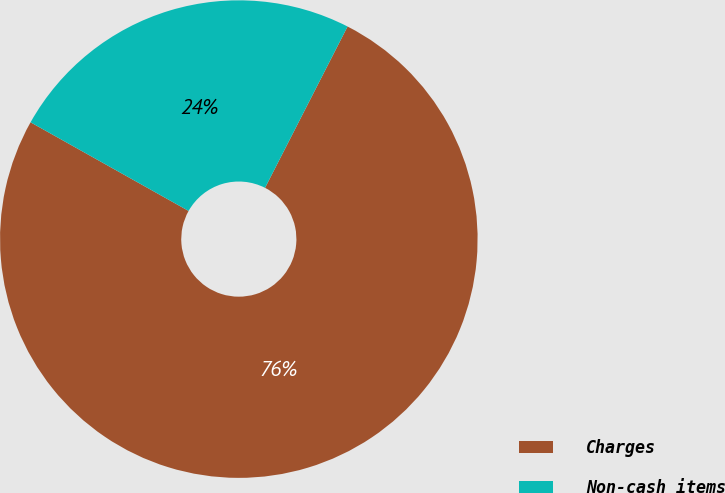<chart> <loc_0><loc_0><loc_500><loc_500><pie_chart><fcel>Charges<fcel>Non-cash items<nl><fcel>75.61%<fcel>24.39%<nl></chart> 